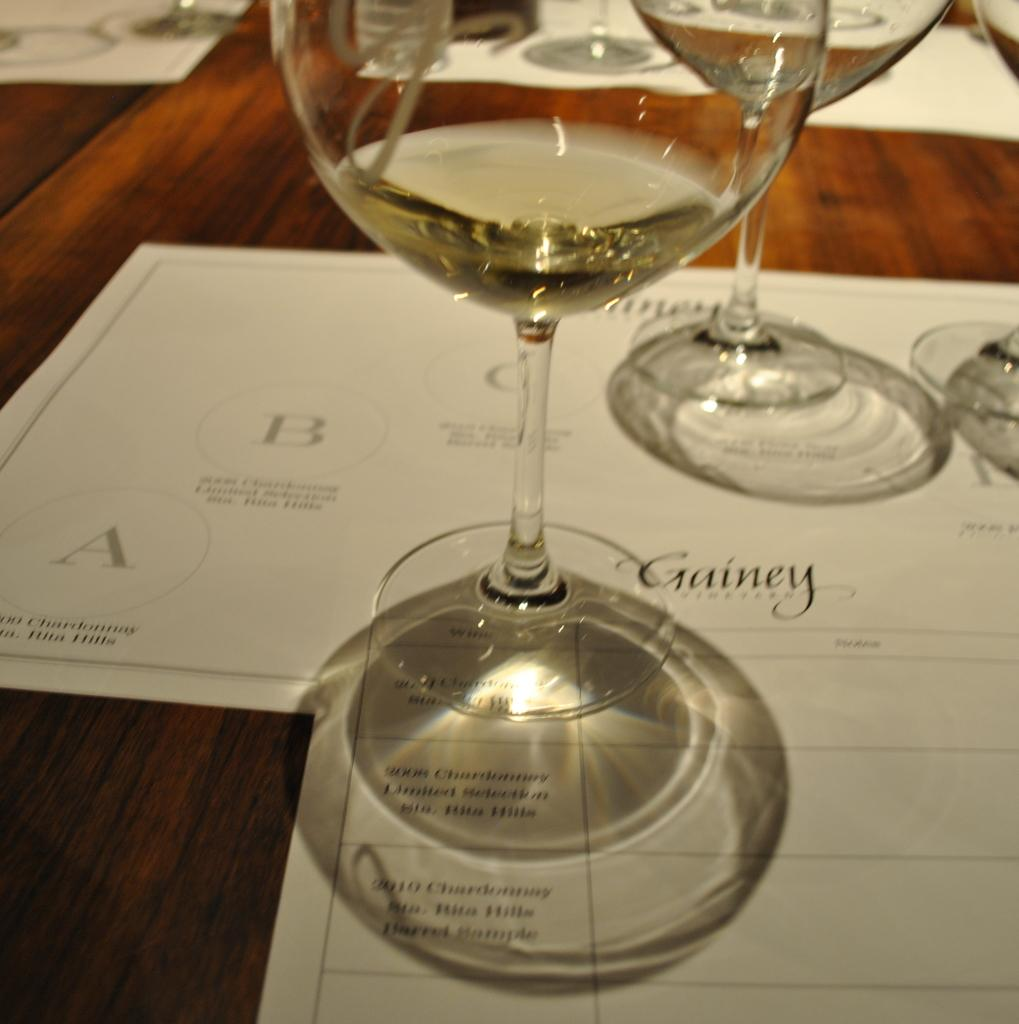What piece of furniture is present in the image? There is a table in the image. How many glasses are on the table? There are three glasses on the table. What are the glasses placed on? The glasses are on papers. What else is present on the table besides the glasses? There are papers on the table. What type of bells can be heard ringing in the image? There are no bells present in the image, and therefore no sound can be heard. 